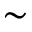Convert formula to latex. <formula><loc_0><loc_0><loc_500><loc_500>\sim</formula> 